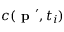Convert formula to latex. <formula><loc_0><loc_0><loc_500><loc_500>c ( p ^ { \prime } , t _ { i } )</formula> 